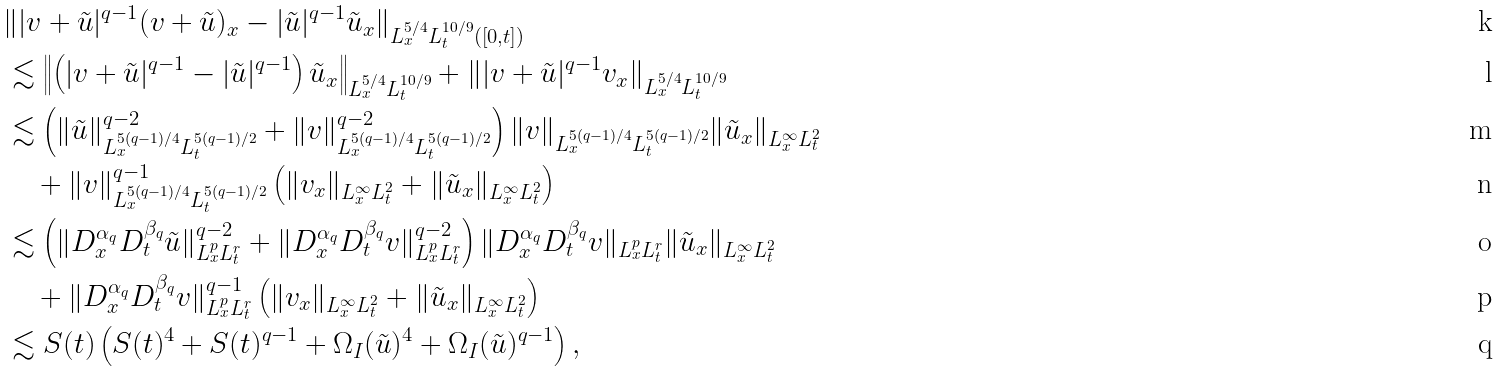<formula> <loc_0><loc_0><loc_500><loc_500>& \| | v + \tilde { u } | ^ { q - 1 } ( v + \tilde { u } ) _ { x } - | \tilde { u } | ^ { q - 1 } \tilde { u } _ { x } \| _ { L ^ { 5 / 4 } _ { x } L ^ { 1 0 / 9 } _ { t } ( [ 0 , t ] ) } \\ & \lesssim \left \| \left ( | v + \tilde { u } | ^ { q - 1 } - | \tilde { u } | ^ { q - 1 } \right ) \tilde { u } _ { x } \right \| _ { L ^ { 5 / 4 } _ { x } L ^ { 1 0 / 9 } _ { t } } + \| | v + \tilde { u } | ^ { q - 1 } v _ { x } \| _ { L ^ { 5 / 4 } _ { x } L ^ { 1 0 / 9 } _ { t } } \\ & \lesssim \left ( \| \tilde { u } \| ^ { q - 2 } _ { L ^ { 5 ( q - 1 ) / 4 } _ { x } L ^ { 5 ( q - 1 ) / 2 } _ { t } } + \| v \| ^ { q - 2 } _ { L ^ { 5 ( q - 1 ) / 4 } _ { x } L ^ { 5 ( q - 1 ) / 2 } _ { t } } \right ) \| v \| _ { L ^ { 5 ( q - 1 ) / 4 } _ { x } L ^ { 5 ( q - 1 ) / 2 } _ { t } } \| \tilde { u } _ { x } \| _ { L ^ { \infty } _ { x } L ^ { 2 } _ { t } } \\ & \quad + \| v \| ^ { q - 1 } _ { L ^ { 5 ( q - 1 ) / 4 } _ { x } L ^ { 5 ( q - 1 ) / 2 } _ { t } } \left ( \| v _ { x } \| _ { L ^ { \infty } _ { x } L ^ { 2 } _ { t } } + \| \tilde { u } _ { x } \| _ { L ^ { \infty } _ { x } L ^ { 2 } _ { t } } \right ) \\ & \lesssim \left ( \| D ^ { \alpha _ { q } } _ { x } D ^ { \beta _ { q } } _ { t } \tilde { u } \| ^ { q - 2 } _ { L ^ { p } _ { x } L ^ { r } _ { t } } + \| D ^ { \alpha _ { q } } _ { x } D ^ { \beta _ { q } } _ { t } v \| ^ { q - 2 } _ { L ^ { p } _ { x } L ^ { r } _ { t } } \right ) \| D ^ { \alpha _ { q } } _ { x } D ^ { \beta _ { q } } _ { t } v \| _ { L ^ { p } _ { x } L ^ { r } _ { t } } \| \tilde { u } _ { x } \| _ { L ^ { \infty } _ { x } L ^ { 2 } _ { t } } \\ & \quad + \| D ^ { \alpha _ { q } } _ { x } D ^ { \beta _ { q } } _ { t } v \| ^ { q - 1 } _ { L ^ { p } _ { x } L ^ { r } _ { t } } \left ( \| v _ { x } \| _ { L ^ { \infty } _ { x } L ^ { 2 } _ { t } } + \| \tilde { u } _ { x } \| _ { L ^ { \infty } _ { x } L ^ { 2 } _ { t } } \right ) \\ & \lesssim S ( t ) \left ( S ( t ) ^ { 4 } + S ( t ) ^ { q - 1 } + \Omega _ { I } ( \tilde { u } ) ^ { 4 } + \Omega _ { I } ( \tilde { u } ) ^ { q - 1 } \right ) ,</formula> 